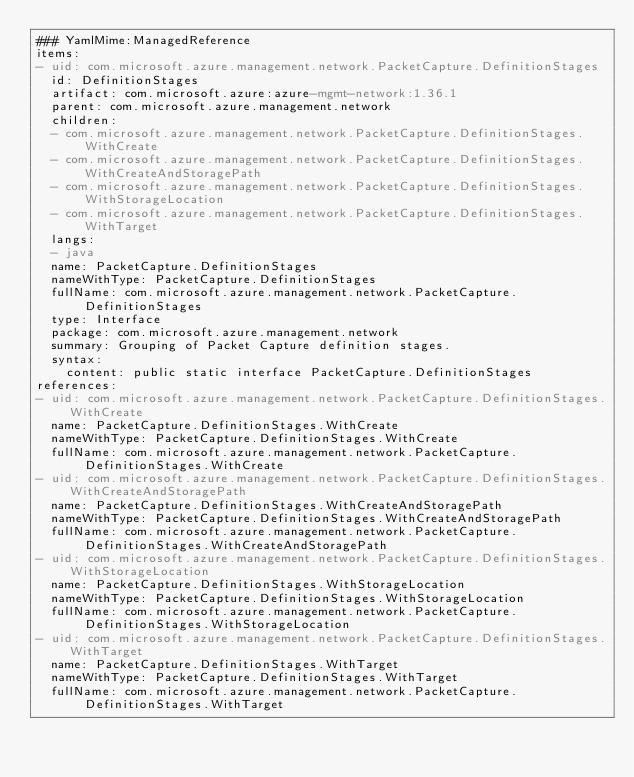<code> <loc_0><loc_0><loc_500><loc_500><_YAML_>### YamlMime:ManagedReference
items:
- uid: com.microsoft.azure.management.network.PacketCapture.DefinitionStages
  id: DefinitionStages
  artifact: com.microsoft.azure:azure-mgmt-network:1.36.1
  parent: com.microsoft.azure.management.network
  children:
  - com.microsoft.azure.management.network.PacketCapture.DefinitionStages.WithCreate
  - com.microsoft.azure.management.network.PacketCapture.DefinitionStages.WithCreateAndStoragePath
  - com.microsoft.azure.management.network.PacketCapture.DefinitionStages.WithStorageLocation
  - com.microsoft.azure.management.network.PacketCapture.DefinitionStages.WithTarget
  langs:
  - java
  name: PacketCapture.DefinitionStages
  nameWithType: PacketCapture.DefinitionStages
  fullName: com.microsoft.azure.management.network.PacketCapture.DefinitionStages
  type: Interface
  package: com.microsoft.azure.management.network
  summary: Grouping of Packet Capture definition stages.
  syntax:
    content: public static interface PacketCapture.DefinitionStages
references:
- uid: com.microsoft.azure.management.network.PacketCapture.DefinitionStages.WithCreate
  name: PacketCapture.DefinitionStages.WithCreate
  nameWithType: PacketCapture.DefinitionStages.WithCreate
  fullName: com.microsoft.azure.management.network.PacketCapture.DefinitionStages.WithCreate
- uid: com.microsoft.azure.management.network.PacketCapture.DefinitionStages.WithCreateAndStoragePath
  name: PacketCapture.DefinitionStages.WithCreateAndStoragePath
  nameWithType: PacketCapture.DefinitionStages.WithCreateAndStoragePath
  fullName: com.microsoft.azure.management.network.PacketCapture.DefinitionStages.WithCreateAndStoragePath
- uid: com.microsoft.azure.management.network.PacketCapture.DefinitionStages.WithStorageLocation
  name: PacketCapture.DefinitionStages.WithStorageLocation
  nameWithType: PacketCapture.DefinitionStages.WithStorageLocation
  fullName: com.microsoft.azure.management.network.PacketCapture.DefinitionStages.WithStorageLocation
- uid: com.microsoft.azure.management.network.PacketCapture.DefinitionStages.WithTarget
  name: PacketCapture.DefinitionStages.WithTarget
  nameWithType: PacketCapture.DefinitionStages.WithTarget
  fullName: com.microsoft.azure.management.network.PacketCapture.DefinitionStages.WithTarget
</code> 